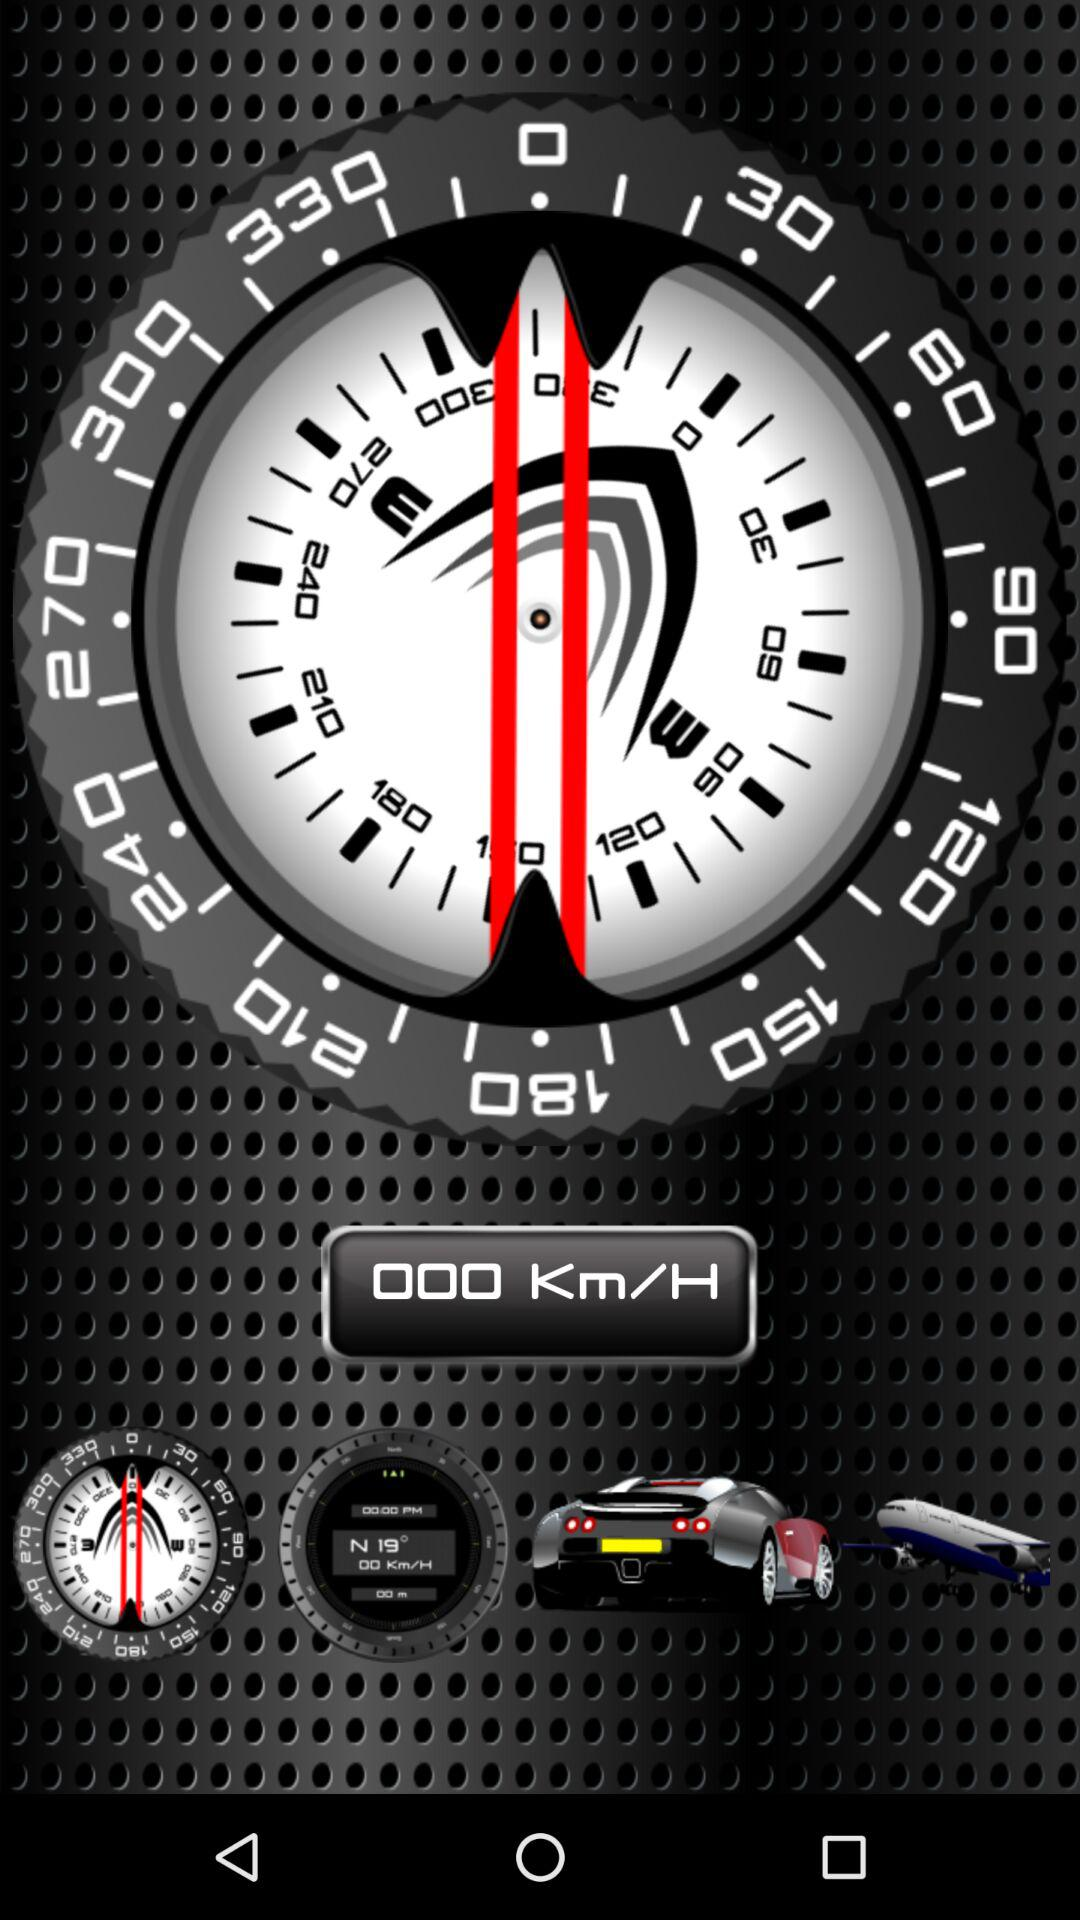What is the value of the speed shown? The value of the speed is 000 Km/H. 